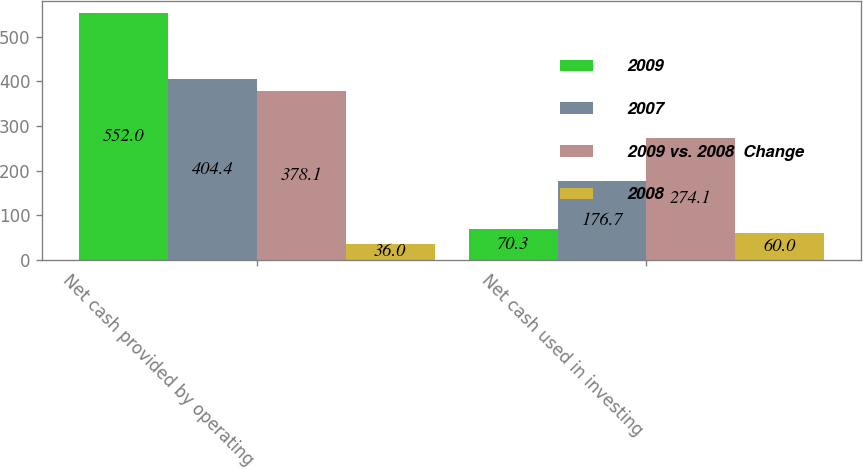Convert chart to OTSL. <chart><loc_0><loc_0><loc_500><loc_500><stacked_bar_chart><ecel><fcel>Net cash provided by operating<fcel>Net cash used in investing<nl><fcel>2009<fcel>552<fcel>70.3<nl><fcel>2007<fcel>404.4<fcel>176.7<nl><fcel>2009 vs. 2008  Change<fcel>378.1<fcel>274.1<nl><fcel>2008<fcel>36<fcel>60<nl></chart> 